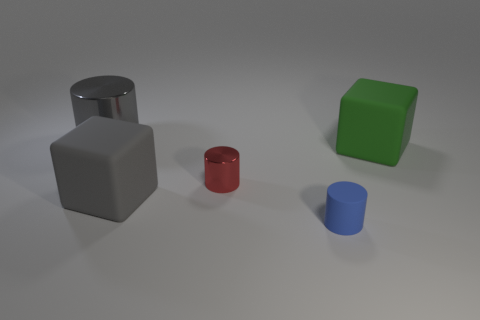What number of other gray rubber things have the same shape as the gray rubber object?
Ensure brevity in your answer.  0. There is a green object on the right side of the gray cylinder; is its size the same as the gray object that is in front of the green matte thing?
Your answer should be compact. Yes. There is a large matte object left of the tiny thing behind the small blue cylinder; what is its shape?
Give a very brief answer. Cube. Are there an equal number of small things that are to the left of the tiny matte cylinder and big red metal balls?
Your response must be concise. No. What material is the big gray object that is behind the large gray object on the right side of the gray thing behind the red metal thing?
Provide a succinct answer. Metal. Is there a green rubber cube of the same size as the gray cube?
Provide a succinct answer. Yes. What shape is the big green object?
Offer a terse response. Cube. What number of cylinders are either blue metal objects or small red metal things?
Offer a very short reply. 1. Are there the same number of red objects on the right side of the blue thing and gray shiny cylinders to the left of the gray metal thing?
Provide a succinct answer. Yes. How many big rubber objects are behind the gray thing in front of the metal thing behind the large green rubber thing?
Provide a succinct answer. 1. 